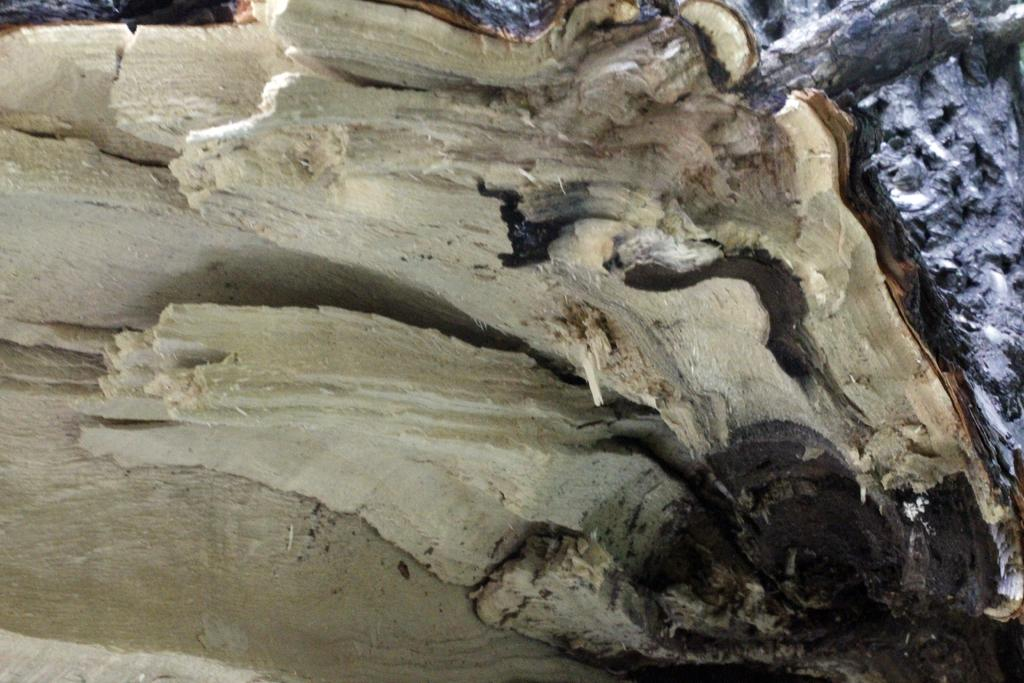What is the main subject in the center of the image? There is a tree in the center of the image. How is the tree in the image different from the trees in the background? The tree in the center of the image appears to be truncated, while the trees in the background are not. What can be seen in the background of the image? There are trees visible in the background of the image. What type of rock is being used as a salad ingredient in the image? There is no rock or salad present in the image; it features a tree in the center and trees in the background. 